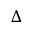Convert formula to latex. <formula><loc_0><loc_0><loc_500><loc_500>\Delta</formula> 